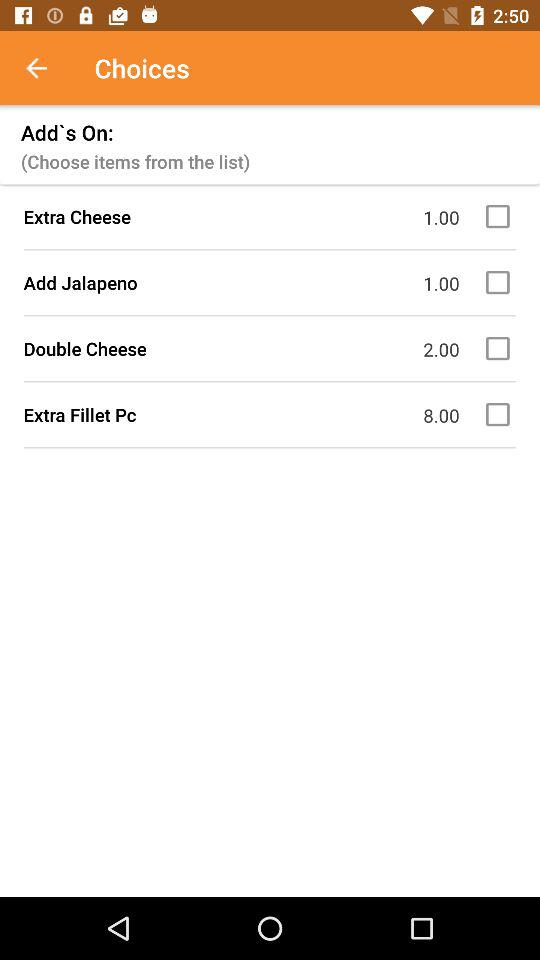What is the price of "Add Jalapeno"? The price is 1. 